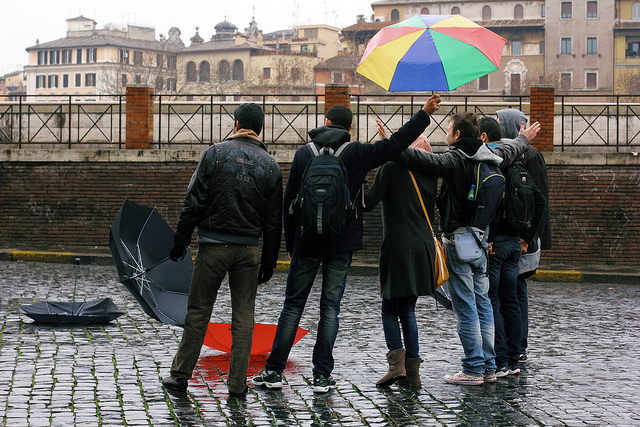What is the weather like in the image, and how are the people dressed for it? The weather appears to be rainy, as evidenced by the wet pavement, umbrellas, and the presence of a discarded umbrella on the ground. The people are dressed in warm and waterproof attire, suggesting they are prepared for the rain. 